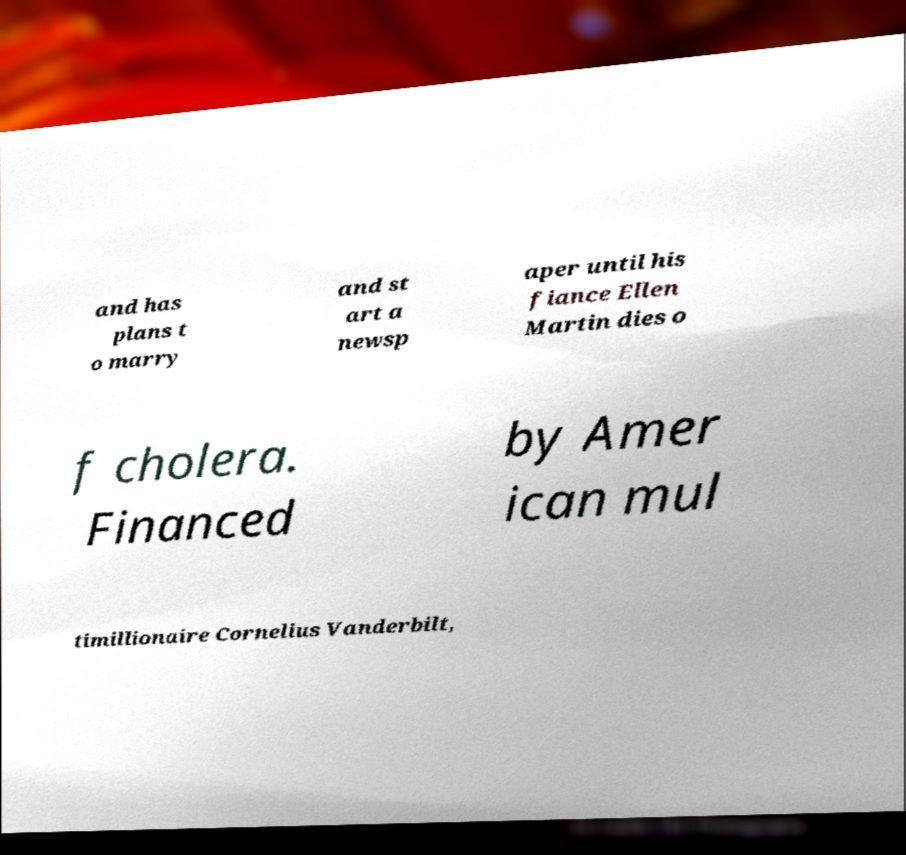Please identify and transcribe the text found in this image. and has plans t o marry and st art a newsp aper until his fiance Ellen Martin dies o f cholera. Financed by Amer ican mul timillionaire Cornelius Vanderbilt, 